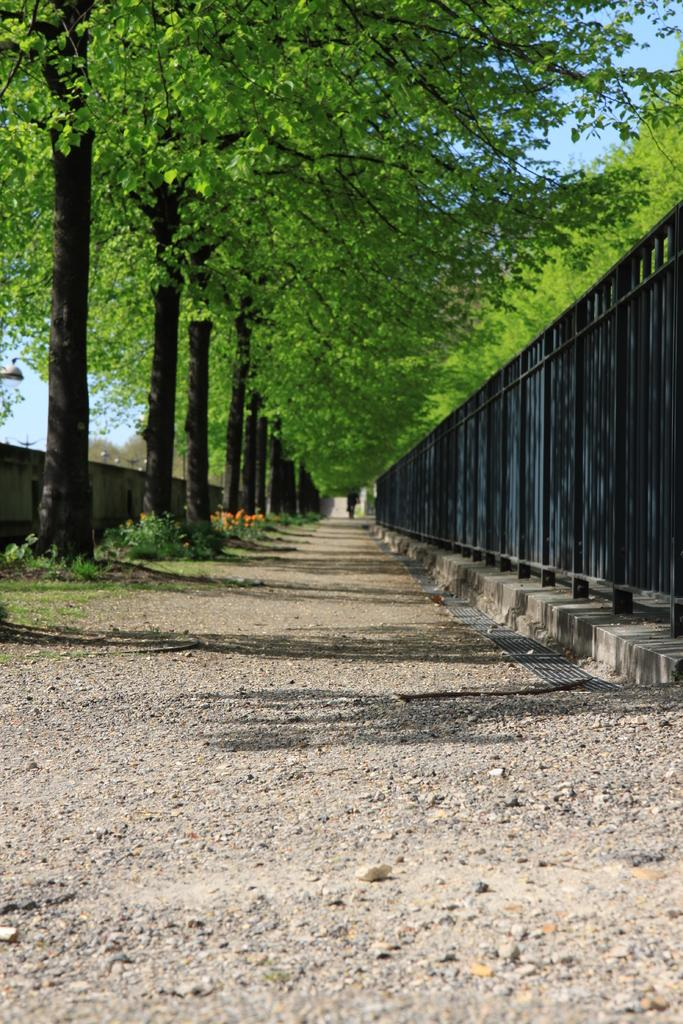What structure is located on the right side of the image? There is a fencing gate on the right side of the image. What type of natural elements can be seen at the top of the image? There are trees visible at the top of the image. What is on the left side of the image? There is a wall on the left side of the image. What type of soup can be seen in the window in the image? There is no window or soup present in the image. What verse is written on the wall in the image? There is no verse written on the wall in the image. 